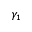Convert formula to latex. <formula><loc_0><loc_0><loc_500><loc_500>\gamma _ { 1 }</formula> 